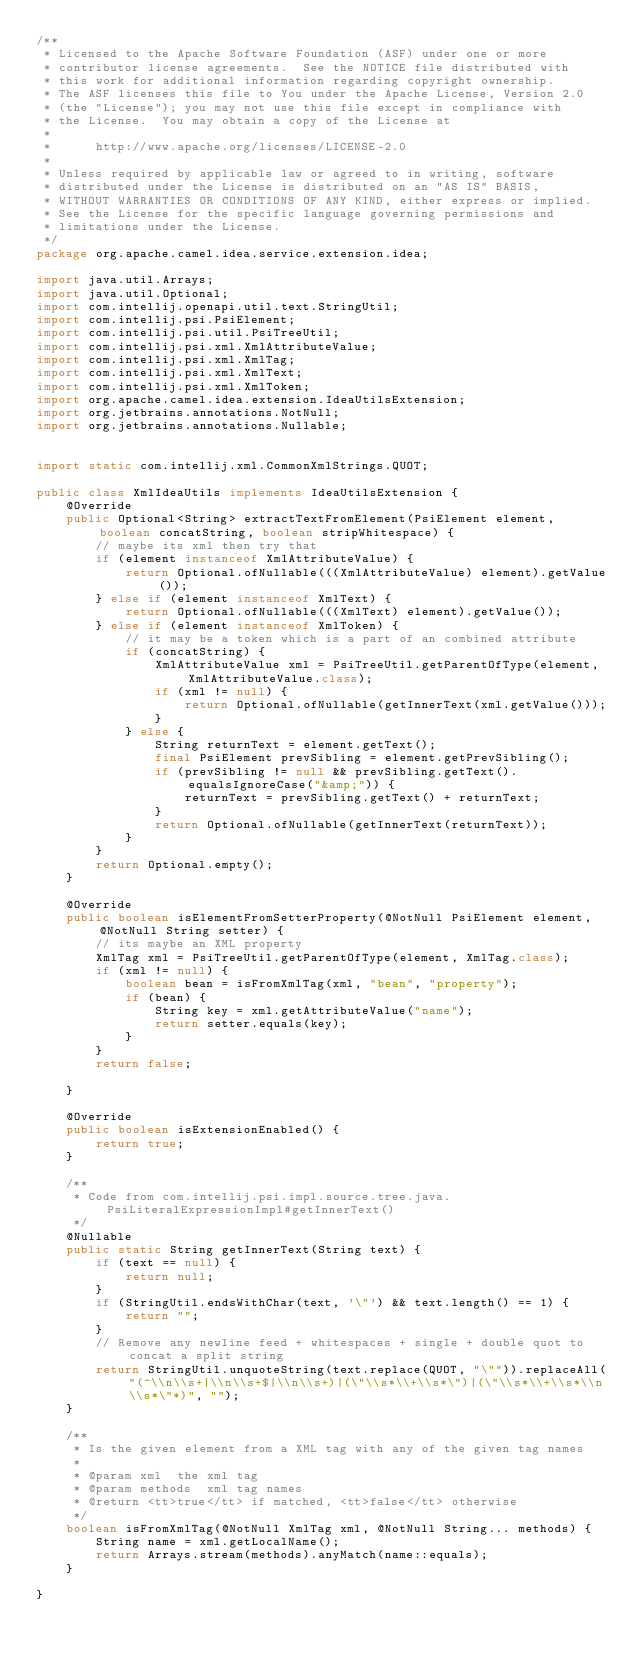Convert code to text. <code><loc_0><loc_0><loc_500><loc_500><_Java_>/**
 * Licensed to the Apache Software Foundation (ASF) under one or more
 * contributor license agreements.  See the NOTICE file distributed with
 * this work for additional information regarding copyright ownership.
 * The ASF licenses this file to You under the Apache License, Version 2.0
 * (the "License"); you may not use this file except in compliance with
 * the License.  You may obtain a copy of the License at
 *
 *      http://www.apache.org/licenses/LICENSE-2.0
 *
 * Unless required by applicable law or agreed to in writing, software
 * distributed under the License is distributed on an "AS IS" BASIS,
 * WITHOUT WARRANTIES OR CONDITIONS OF ANY KIND, either express or implied.
 * See the License for the specific language governing permissions and
 * limitations under the License.
 */
package org.apache.camel.idea.service.extension.idea;

import java.util.Arrays;
import java.util.Optional;
import com.intellij.openapi.util.text.StringUtil;
import com.intellij.psi.PsiElement;
import com.intellij.psi.util.PsiTreeUtil;
import com.intellij.psi.xml.XmlAttributeValue;
import com.intellij.psi.xml.XmlTag;
import com.intellij.psi.xml.XmlText;
import com.intellij.psi.xml.XmlToken;
import org.apache.camel.idea.extension.IdeaUtilsExtension;
import org.jetbrains.annotations.NotNull;
import org.jetbrains.annotations.Nullable;


import static com.intellij.xml.CommonXmlStrings.QUOT;

public class XmlIdeaUtils implements IdeaUtilsExtension {
    @Override
    public Optional<String> extractTextFromElement(PsiElement element, boolean concatString, boolean stripWhitespace) {
        // maybe its xml then try that
        if (element instanceof XmlAttributeValue) {
            return Optional.ofNullable(((XmlAttributeValue) element).getValue());
        } else if (element instanceof XmlText) {
            return Optional.ofNullable(((XmlText) element).getValue());
        } else if (element instanceof XmlToken) {
            // it may be a token which is a part of an combined attribute
            if (concatString) {
                XmlAttributeValue xml = PsiTreeUtil.getParentOfType(element, XmlAttributeValue.class);
                if (xml != null) {
                    return Optional.ofNullable(getInnerText(xml.getValue()));
                }
            } else {
                String returnText = element.getText();
                final PsiElement prevSibling = element.getPrevSibling();
                if (prevSibling != null && prevSibling.getText().equalsIgnoreCase("&amp;")) {
                    returnText = prevSibling.getText() + returnText;
                }
                return Optional.ofNullable(getInnerText(returnText));
            }
        }
        return Optional.empty();
    }

    @Override
    public boolean isElementFromSetterProperty(@NotNull PsiElement element, @NotNull String setter) {
        // its maybe an XML property
        XmlTag xml = PsiTreeUtil.getParentOfType(element, XmlTag.class);
        if (xml != null) {
            boolean bean = isFromXmlTag(xml, "bean", "property");
            if (bean) {
                String key = xml.getAttributeValue("name");
                return setter.equals(key);
            }
        }
        return false;

    }

    @Override
    public boolean isExtensionEnabled() {
        return true;
    }

    /**
     * Code from com.intellij.psi.impl.source.tree.java.PsiLiteralExpressionImpl#getInnerText()
     */
    @Nullable
    public static String getInnerText(String text) {
        if (text == null) {
            return null;
        }
        if (StringUtil.endsWithChar(text, '\"') && text.length() == 1) {
            return "";
        }
        // Remove any newline feed + whitespaces + single + double quot to concat a split string
        return StringUtil.unquoteString(text.replace(QUOT, "\"")).replaceAll("(^\\n\\s+|\\n\\s+$|\\n\\s+)|(\"\\s*\\+\\s*\")|(\"\\s*\\+\\s*\\n\\s*\"*)", "");
    }

    /**
     * Is the given element from a XML tag with any of the given tag names
     *
     * @param xml  the xml tag
     * @param methods  xml tag names
     * @return <tt>true</tt> if matched, <tt>false</tt> otherwise
     */
    boolean isFromXmlTag(@NotNull XmlTag xml, @NotNull String... methods) {
        String name = xml.getLocalName();
        return Arrays.stream(methods).anyMatch(name::equals);
    }

}
</code> 